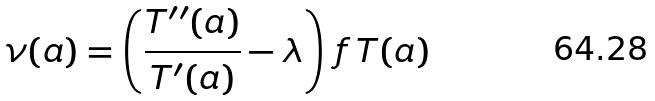Convert formula to latex. <formula><loc_0><loc_0><loc_500><loc_500>\nu ( a ) = \left ( \frac { T ^ { \prime \prime } ( a ) } { T ^ { \prime } ( a ) } - \lambda \right ) \, f \, T ( a )</formula> 